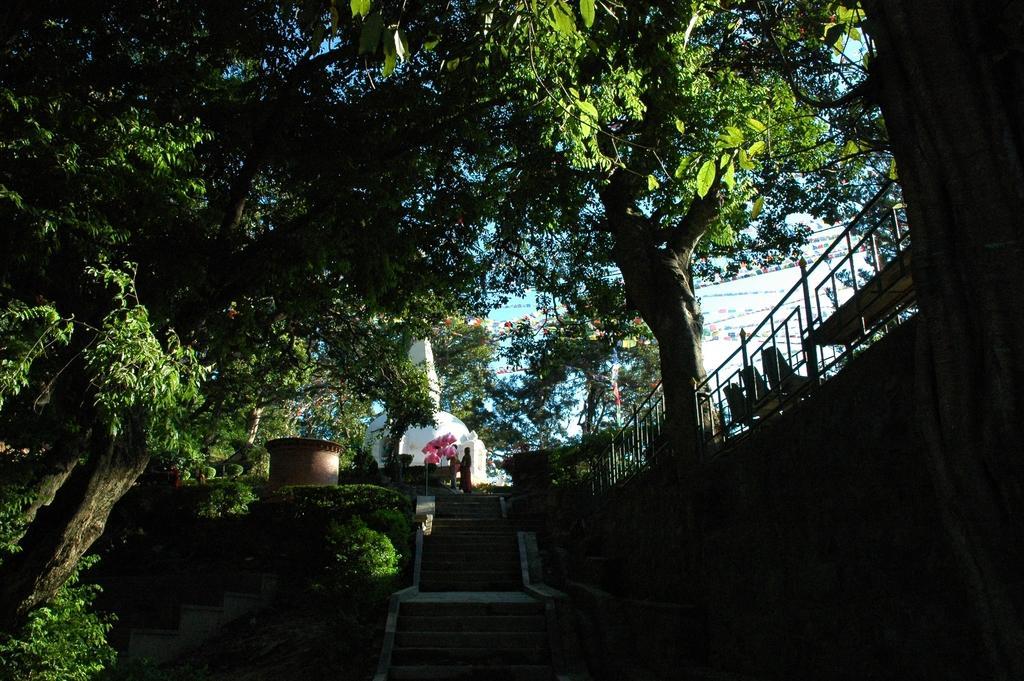Describe this image in one or two sentences. In this picture, there are stairs at the bottom. On the stairs, there is a woman. Towards the left, there are trees. Towards the right, there is a wall with hand-grill. Beside it, there are chairs. 